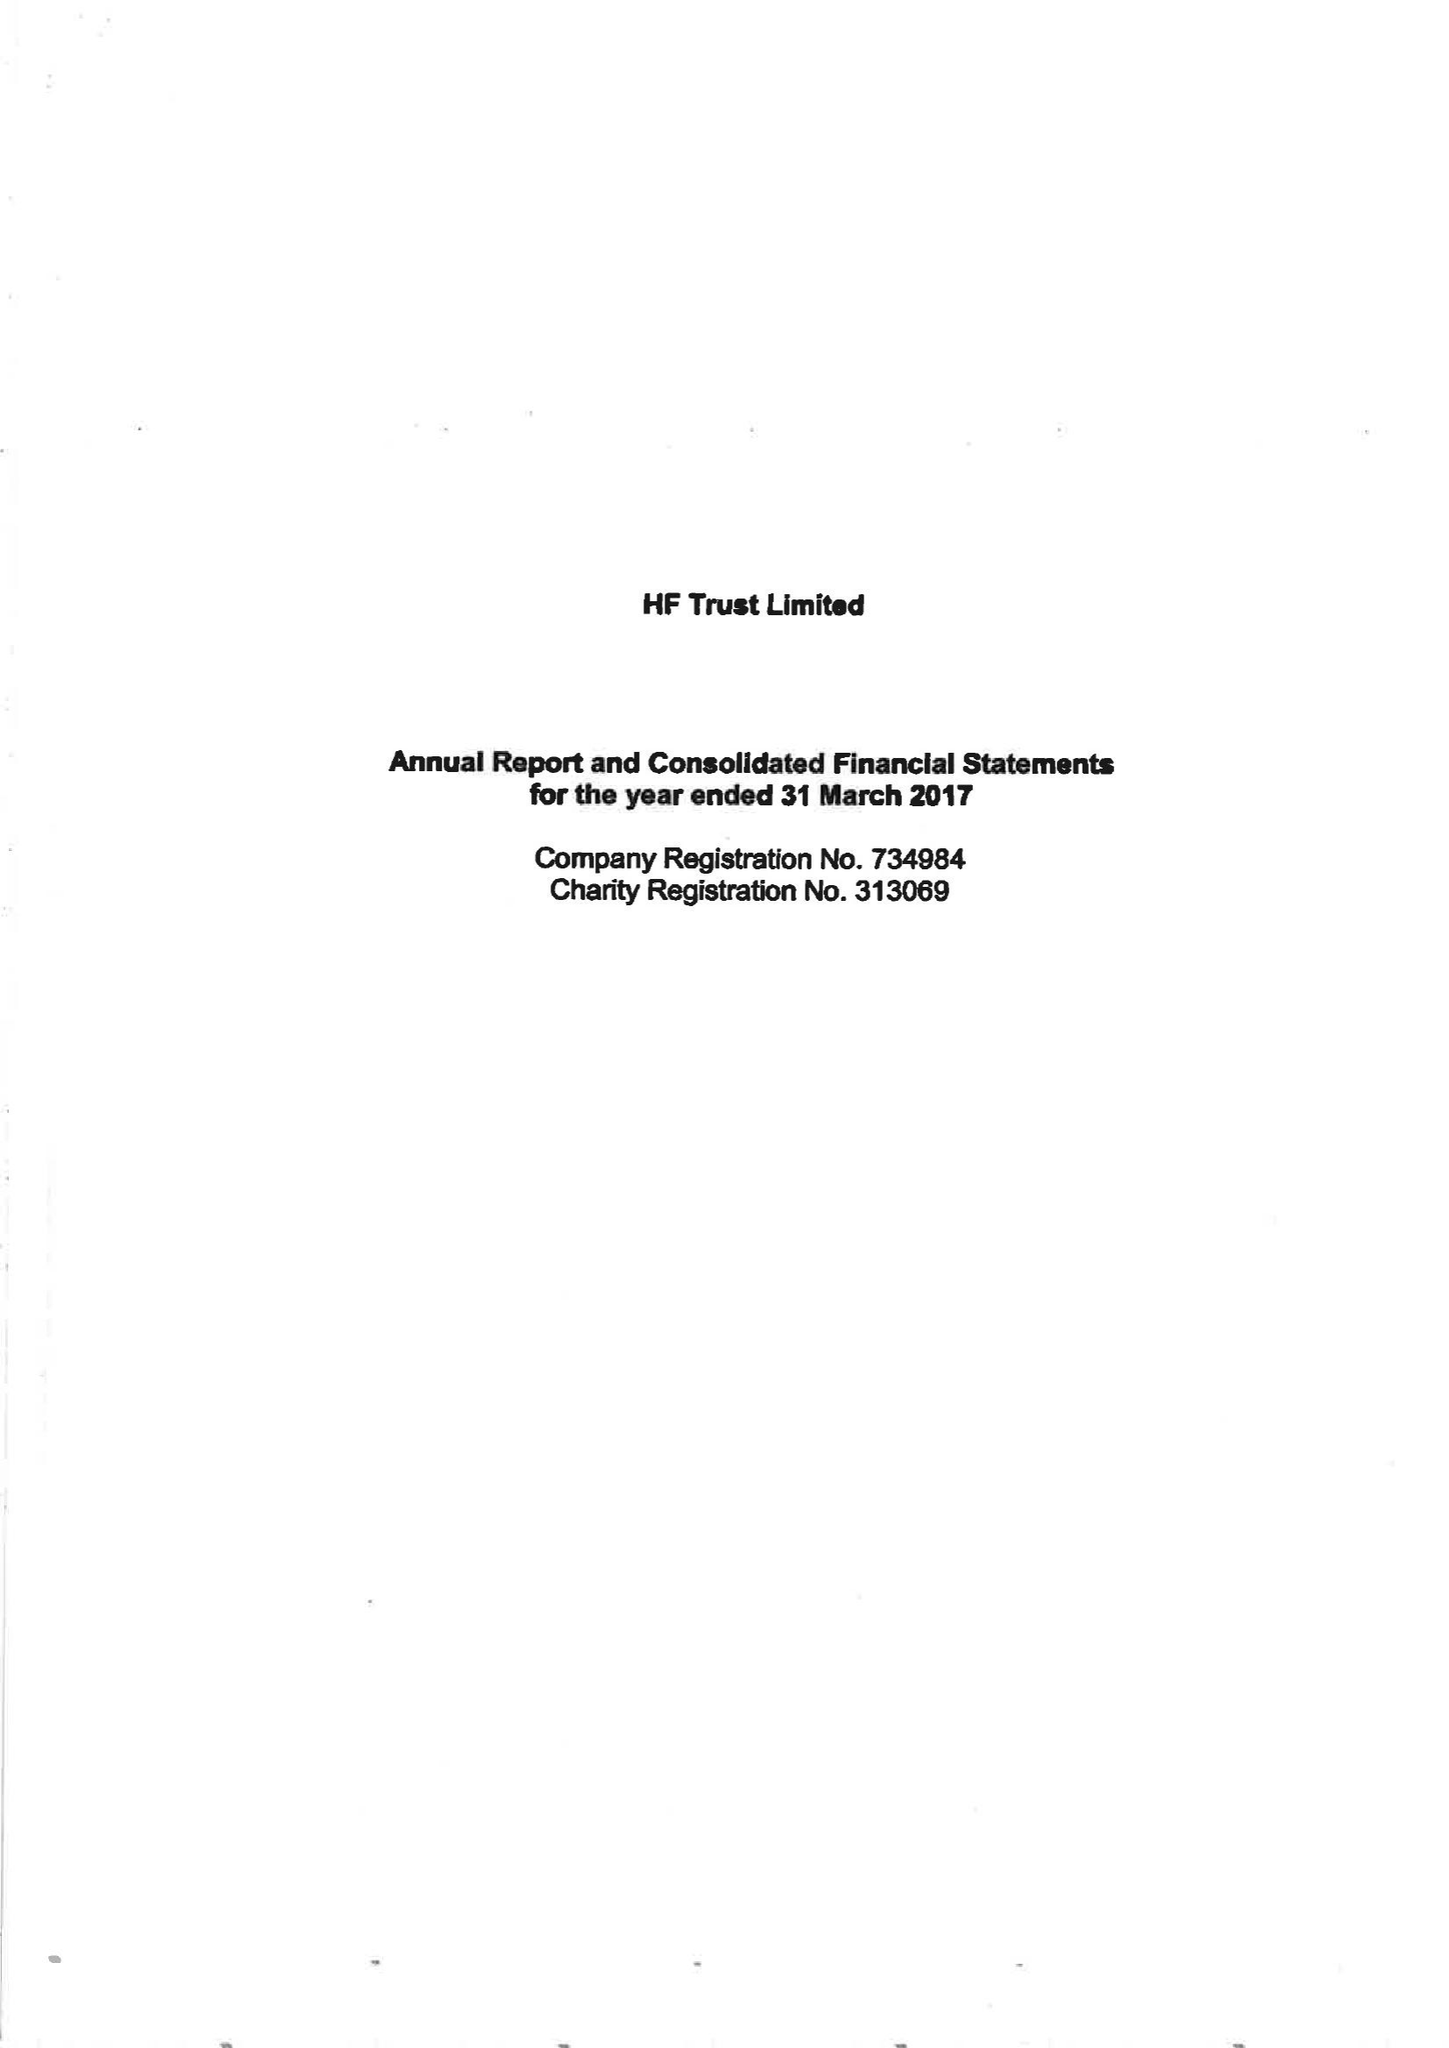What is the value for the charity_name?
Answer the question using a single word or phrase. Hf Trust Ltd. 